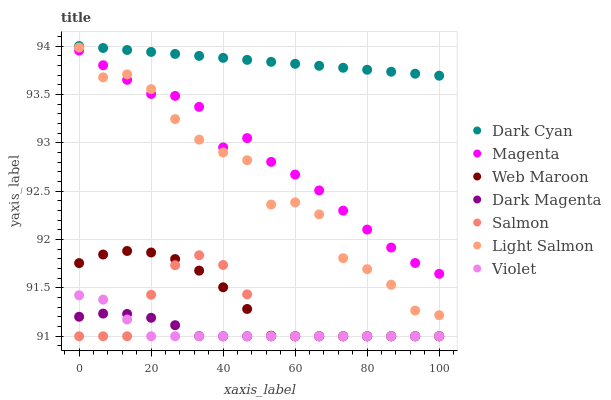Does Violet have the minimum area under the curve?
Answer yes or no. Yes. Does Dark Cyan have the maximum area under the curve?
Answer yes or no. Yes. Does Dark Magenta have the minimum area under the curve?
Answer yes or no. No. Does Dark Magenta have the maximum area under the curve?
Answer yes or no. No. Is Dark Cyan the smoothest?
Answer yes or no. Yes. Is Light Salmon the roughest?
Answer yes or no. Yes. Is Dark Magenta the smoothest?
Answer yes or no. No. Is Dark Magenta the roughest?
Answer yes or no. No. Does Dark Magenta have the lowest value?
Answer yes or no. Yes. Does Dark Cyan have the lowest value?
Answer yes or no. No. Does Dark Cyan have the highest value?
Answer yes or no. Yes. Does Web Maroon have the highest value?
Answer yes or no. No. Is Magenta less than Dark Cyan?
Answer yes or no. Yes. Is Dark Cyan greater than Magenta?
Answer yes or no. Yes. Does Salmon intersect Dark Magenta?
Answer yes or no. Yes. Is Salmon less than Dark Magenta?
Answer yes or no. No. Is Salmon greater than Dark Magenta?
Answer yes or no. No. Does Magenta intersect Dark Cyan?
Answer yes or no. No. 